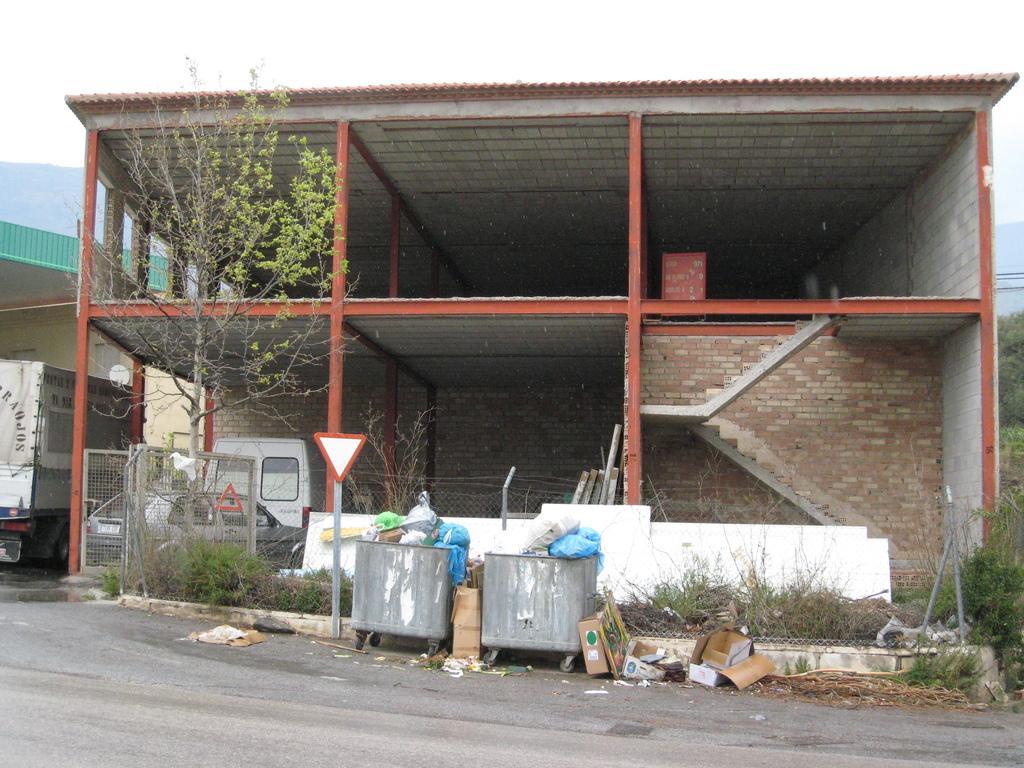Please provide a concise description of this image. In this image, I can see a building with stairs. In front of a building, I can see a tree, signboard, two dustbins, cardboard boxes, plants, fence and an iron gate. There are vehicles. At the bottom of the image, this is the road. In the background, I can see the hills. 